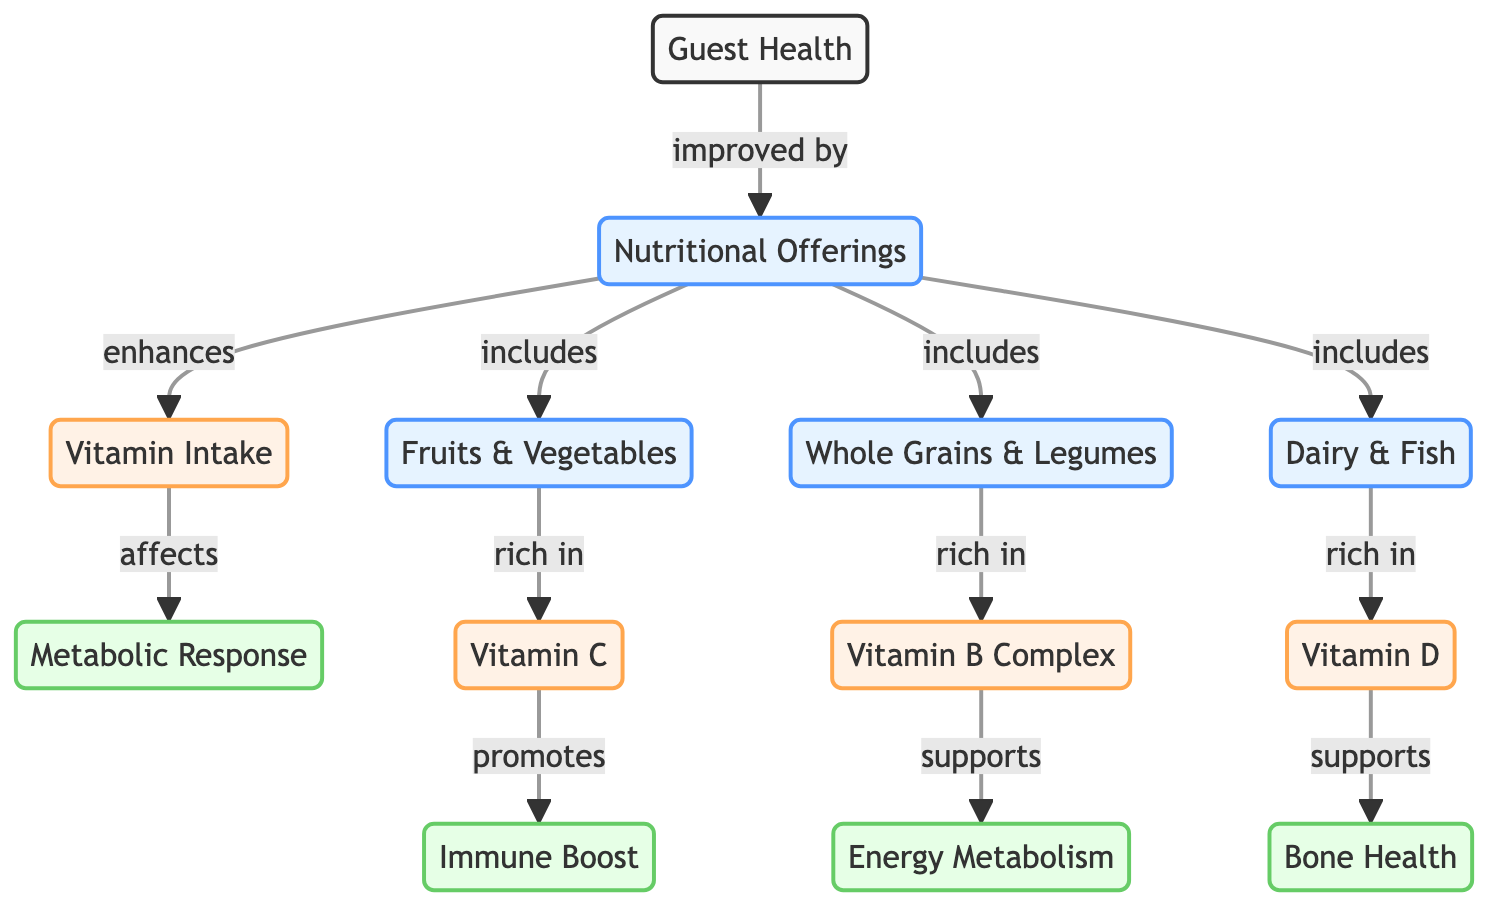What nodes are included under nutritional offerings? Looking at the diagram, the node "nutritional offerings" has three connecting nodes: "Fruits & Vegetables," "Whole Grains & Legumes," and "Dairy & Fish." These nodes depict the different nutritional offerings available.
Answer: Fruits & Vegetables, Whole Grains & Legumes, Dairy & Fish How does vitamin C affect guest health? Vitamin C, which is found under the "Fruits & Vegetables" node, promotes an "Immune Boost," enhancing overall guest health. This relationship is indicated by the directional flow from vitamin C to immune boost.
Answer: Immune Boost What is the relationship between vitamin B complex and energy metabolism? The diagram shows that vitamin B complex, a component of "Whole Grains & Legumes," supports "Energy Metabolism." This indicates a direct relationship where one facilitates the other.
Answer: Supports How many edges connect to the guest health node? By analyzing the diagram, the "Guest Health" node is connected by one edge leading to "Nutritional Offerings." Therefore, there is a single flow from guest health to nutritional offerings.
Answer: 1 Describe how vitamin D contributes to guest health. The relationship shows that vitamin D, which is associated with the "Dairy & Fish" node, supports "Bone Health." This means that by enhancing bone health, vitamin D directly contributes to overall guest health.
Answer: Bone Health What type of response is influenced by vitamin intake? The diagram indicates that "Metabolic Response" is influenced by the "Vitamin Intake." The directional flow highlights the effect of vitamin intake on metabolic processes within the guests.
Answer: Metabolic Response How many nutritional offerings are linked to the vitamin intake? On reviewing the diagram, we can identify three nutritional offerings—"Fruits & Vegetables," "Whole Grains & Legumes," and "Dairy & Fish"—that link to the "Vitamin Intake." Each provides distinct vitamins that contribute to the overall nutrient profile.
Answer: 3 What is the role of nutritional offerings in improving guest health? The diagram illustrates that "Nutritional Offerings" improve "Guest Health," establishing a direct relationship where better nutrition leads to better health outcomes for guests.
Answer: Improve Which vitamin is linked to immune system benefits? The diagram connects "Vitamin C" with the "Immune Boost." This signifies that vitamin C has a direct role in enhancing the immune system of guests consuming nutritional offerings.
Answer: Vitamin C 